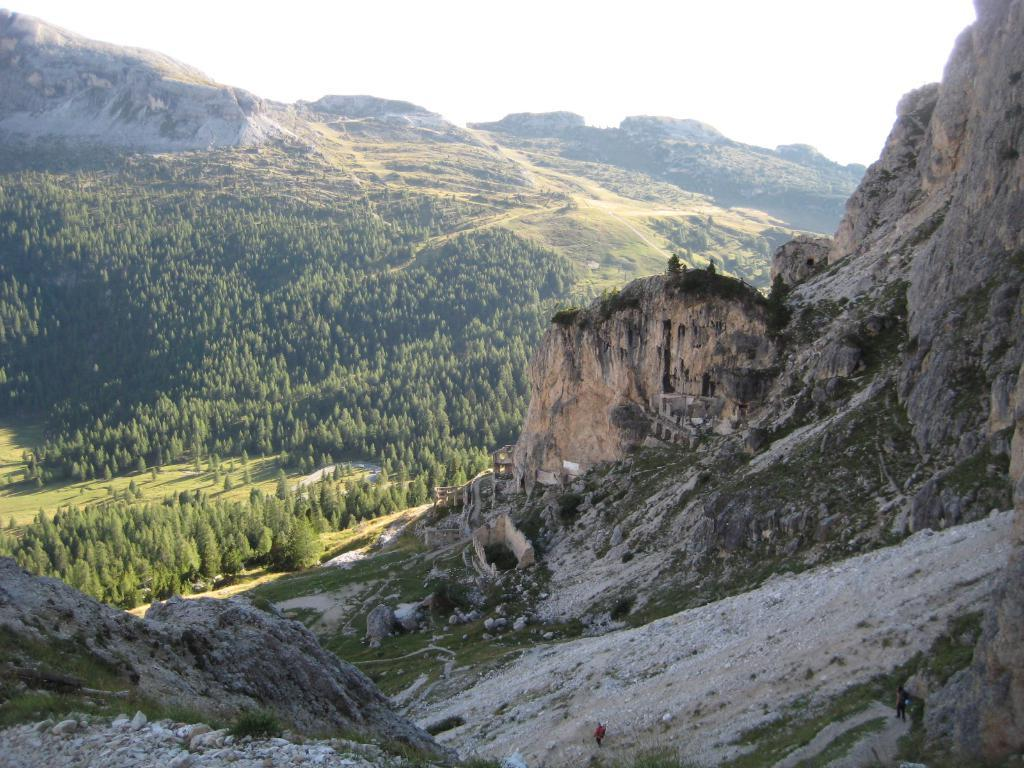What type of natural landscape is depicted in the image? The image features mountains. What other natural elements can be seen in the image? There are trees in the image. What is the color of the sky in the image? The sky is white in color. What type of soup is being advertised in the image? There is no soup or advertisement present in the image. Can you tell me the name of the judge featured in the image? There is no judge present in the image. 